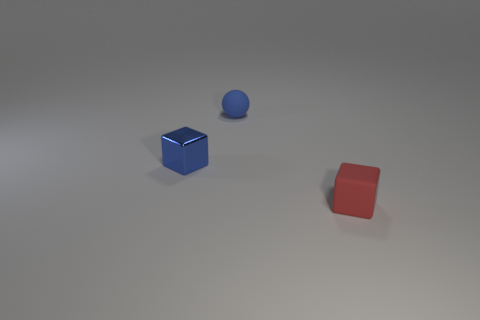Add 1 tiny blue shiny cubes. How many objects exist? 4 Subtract all balls. How many objects are left? 2 Subtract 0 blue cylinders. How many objects are left? 3 Subtract all cubes. Subtract all blue shiny blocks. How many objects are left? 0 Add 1 tiny blue spheres. How many tiny blue spheres are left? 2 Add 2 tiny red matte blocks. How many tiny red matte blocks exist? 3 